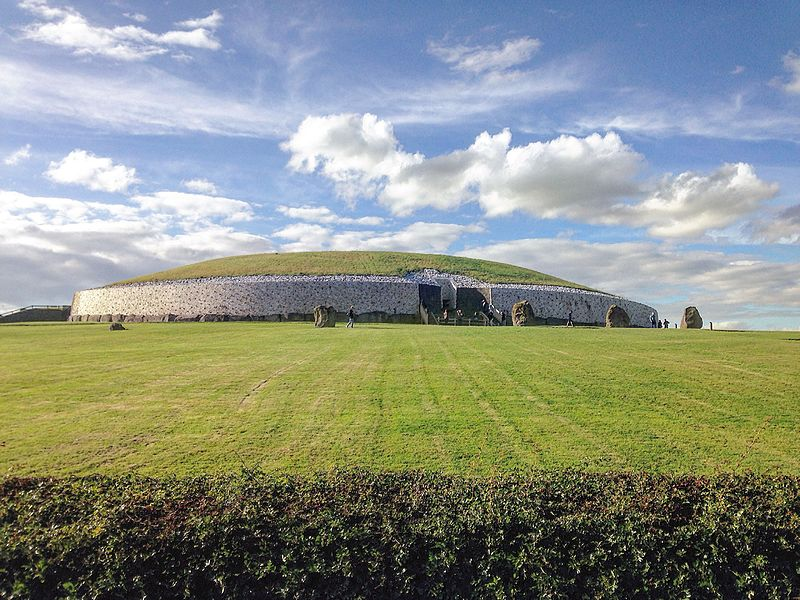What happens during the winter solstice at Newgrange? During the winter solstice, a spectacular event occurs at Newgrange. On the shortest days of the year, sunlight enters the roof-box of Newgrange and travels down the long passage into the main chamber. This alignment illuminates the chamber with a golden glow, an event that lasts for about 17 minutes, and is thought to have had spiritual significance, symbolizing rebirth and renewal to the ancient builders. 